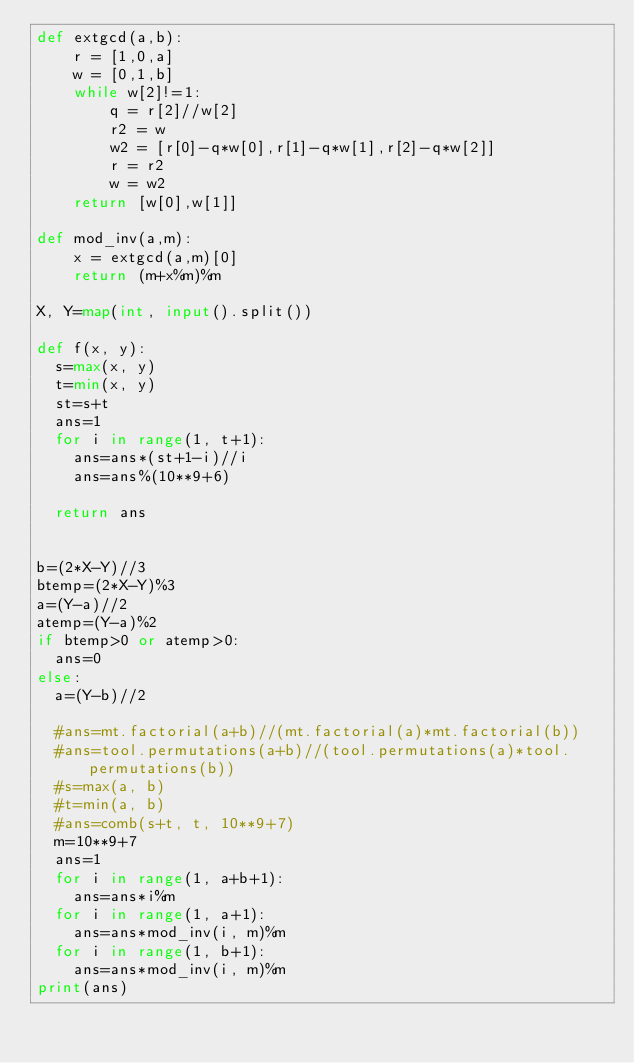<code> <loc_0><loc_0><loc_500><loc_500><_Python_>def extgcd(a,b):
    r = [1,0,a]
    w = [0,1,b]
    while w[2]!=1:
        q = r[2]//w[2]
        r2 = w
        w2 = [r[0]-q*w[0],r[1]-q*w[1],r[2]-q*w[2]]
        r = r2
        w = w2
    return [w[0],w[1]]

def mod_inv(a,m):
    x = extgcd(a,m)[0]
    return (m+x%m)%m

X, Y=map(int, input().split())
 
def f(x, y):
  s=max(x, y)
  t=min(x, y)
  st=s+t
  ans=1
  for i in range(1, t+1):
    ans=ans*(st+1-i)//i
    ans=ans%(10**9+6)
    
  return ans
  
      
b=(2*X-Y)//3
btemp=(2*X-Y)%3
a=(Y-a)//2
atemp=(Y-a)%2
if btemp>0 or atemp>0:
  ans=0
else:
  a=(Y-b)//2
  
  #ans=mt.factorial(a+b)//(mt.factorial(a)*mt.factorial(b))
  #ans=tool.permutations(a+b)//(tool.permutations(a)*tool.permutations(b))
  #s=max(a, b)
  #t=min(a, b)
  #ans=comb(s+t, t, 10**9+7)
  m=10**9+7
  ans=1
  for i in range(1, a+b+1):
    ans=ans*i%m
  for i in range(1, a+1):
    ans=ans*mod_inv(i, m)%m
  for i in range(1, b+1):
    ans=ans*mod_inv(i, m)%m
print(ans)
</code> 